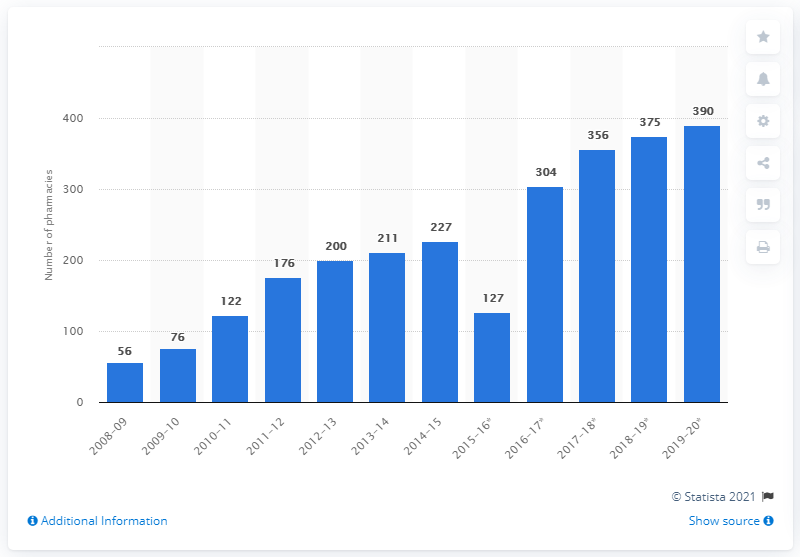Mention a couple of crucial points in this snapshot. There were 390 distance selling pharmacies in 2019/20. 